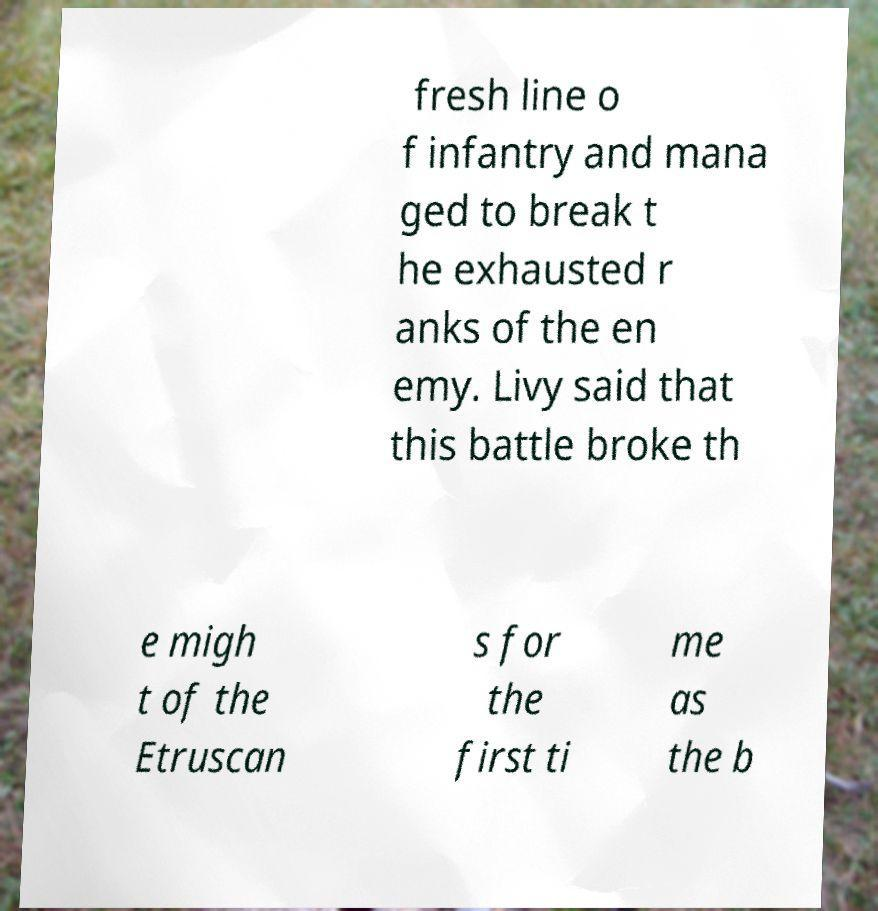There's text embedded in this image that I need extracted. Can you transcribe it verbatim? fresh line o f infantry and mana ged to break t he exhausted r anks of the en emy. Livy said that this battle broke th e migh t of the Etruscan s for the first ti me as the b 